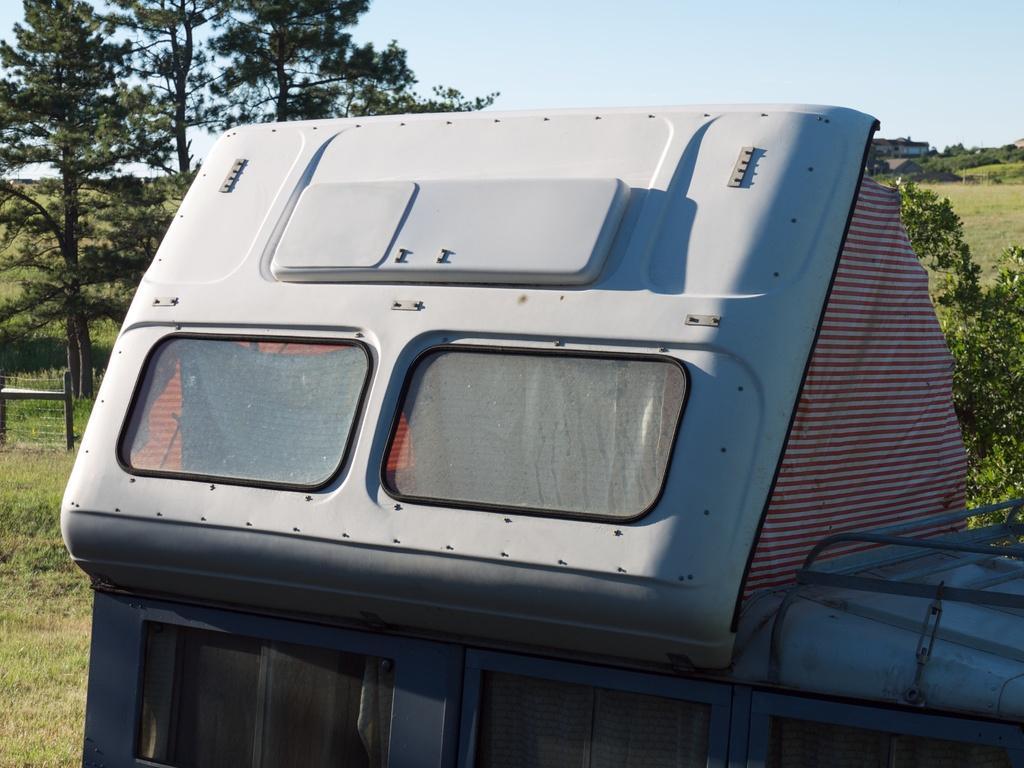Describe this image in one or two sentences. In this picture, there is a truck in the center. In the background there are trees, grass and sky. 